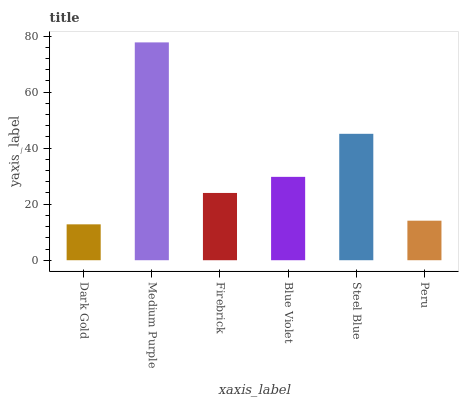Is Dark Gold the minimum?
Answer yes or no. Yes. Is Medium Purple the maximum?
Answer yes or no. Yes. Is Firebrick the minimum?
Answer yes or no. No. Is Firebrick the maximum?
Answer yes or no. No. Is Medium Purple greater than Firebrick?
Answer yes or no. Yes. Is Firebrick less than Medium Purple?
Answer yes or no. Yes. Is Firebrick greater than Medium Purple?
Answer yes or no. No. Is Medium Purple less than Firebrick?
Answer yes or no. No. Is Blue Violet the high median?
Answer yes or no. Yes. Is Firebrick the low median?
Answer yes or no. Yes. Is Medium Purple the high median?
Answer yes or no. No. Is Blue Violet the low median?
Answer yes or no. No. 